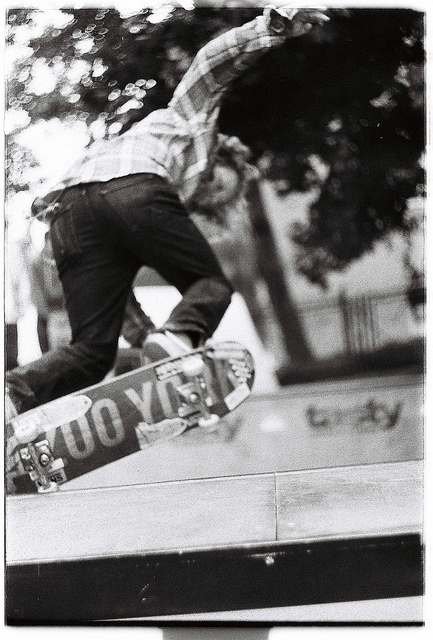Describe the objects in this image and their specific colors. I can see people in white, black, lightgray, gray, and darkgray tones and skateboard in white, gray, lightgray, darkgray, and black tones in this image. 